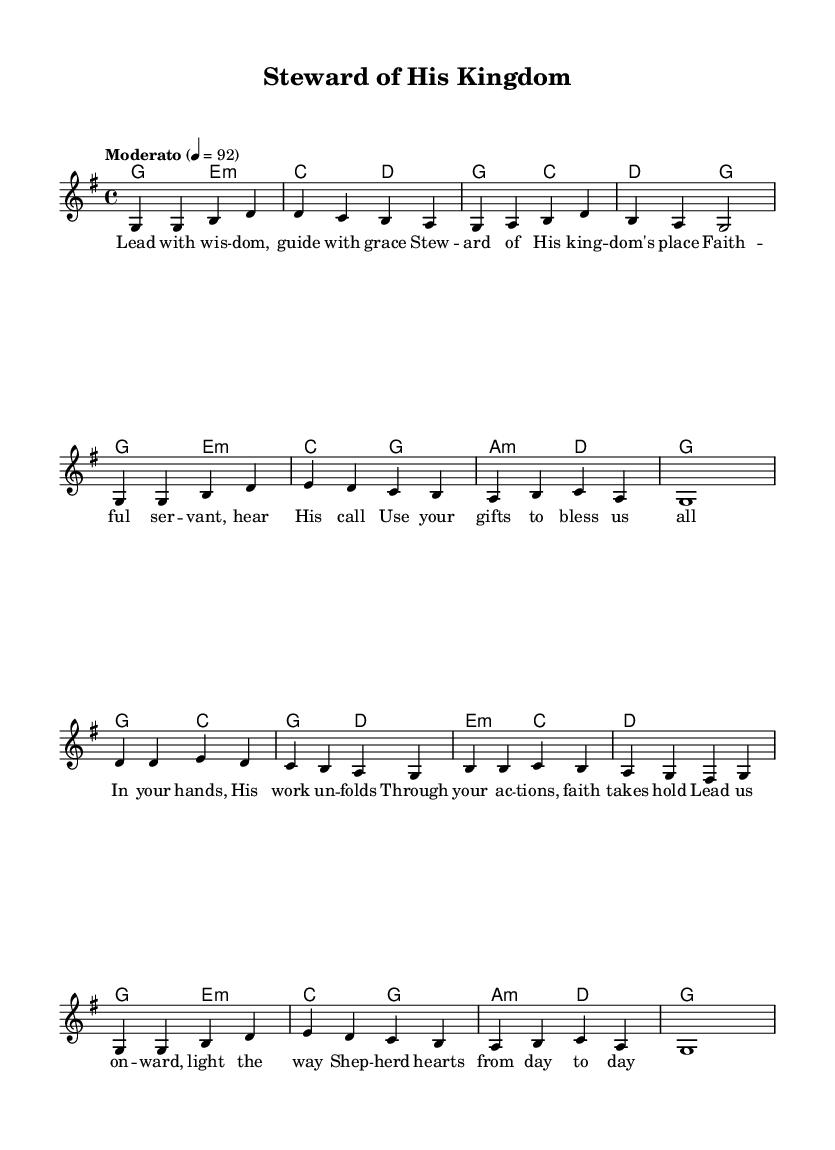What is the key signature of this music? The key signature is G major, which has one sharp (F#). This can be identified by looking at the key signature indicated at the beginning of the sheet music.
Answer: G major What is the time signature of this music? The time signature is 4/4, which can be found at the beginning of the score right after the key signature. It indicates that there are four beats in a measure and a quarter note gets one beat.
Answer: 4/4 What is the tempo marking of this piece? The tempo marking is "Moderato," indicated at the beginning of the score. Additionally, it specifies a metronome marking of 92 beats per minute, giving guidance on how fast the piece should be played.
Answer: Moderato How many measures are there in total? To determine the total number of measures, one must count all the distinct measure lines from the beginning to the end of the score. There are 16 measures in total.
Answer: 16 What is the repeated harmonic pattern in the piece? The harmonies seem to repeat the sequence of G, E minor, C, D across multiple sections. This pattern occurs frequently throughout the piece, reinforcing the foundational chords.
Answer: G, E minor, C, D What themes are highlighted in the lyrics of the song? The lyrics focus on leadership, guidance, and stewardship as a faithful servant. They emphasize using one's gifts to bless others and shepherding hearts. The themes can be deduced by closely reading the verses.
Answer: Leadership, stewardship 